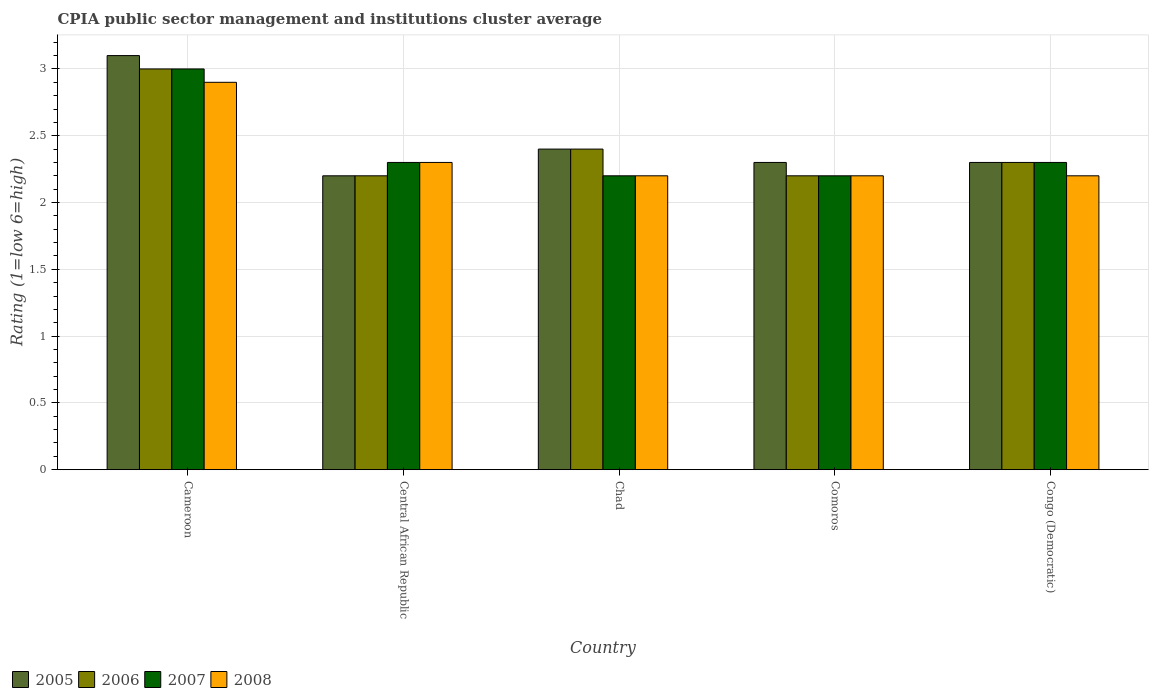How many different coloured bars are there?
Offer a very short reply. 4. How many groups of bars are there?
Provide a succinct answer. 5. Are the number of bars per tick equal to the number of legend labels?
Give a very brief answer. Yes. Are the number of bars on each tick of the X-axis equal?
Offer a very short reply. Yes. How many bars are there on the 3rd tick from the left?
Provide a succinct answer. 4. What is the label of the 5th group of bars from the left?
Your answer should be compact. Congo (Democratic). Across all countries, what is the minimum CPIA rating in 2007?
Offer a terse response. 2.2. In which country was the CPIA rating in 2008 maximum?
Provide a succinct answer. Cameroon. In which country was the CPIA rating in 2008 minimum?
Your response must be concise. Chad. What is the difference between the CPIA rating in 2006 in Chad and that in Comoros?
Make the answer very short. 0.2. What is the difference between the CPIA rating in 2005 in Chad and the CPIA rating in 2008 in Cameroon?
Provide a short and direct response. -0.5. What is the average CPIA rating in 2007 per country?
Make the answer very short. 2.4. What is the difference between the CPIA rating of/in 2006 and CPIA rating of/in 2008 in Cameroon?
Provide a succinct answer. 0.1. What is the ratio of the CPIA rating in 2007 in Chad to that in Comoros?
Provide a short and direct response. 1. Is the CPIA rating in 2007 in Cameroon less than that in Chad?
Provide a succinct answer. No. What is the difference between the highest and the second highest CPIA rating in 2007?
Offer a terse response. -0.7. What is the difference between the highest and the lowest CPIA rating in 2008?
Make the answer very short. 0.7. Is the sum of the CPIA rating in 2008 in Central African Republic and Comoros greater than the maximum CPIA rating in 2005 across all countries?
Offer a very short reply. Yes. Is it the case that in every country, the sum of the CPIA rating in 2007 and CPIA rating in 2006 is greater than the sum of CPIA rating in 2008 and CPIA rating in 2005?
Ensure brevity in your answer.  No. How many countries are there in the graph?
Offer a terse response. 5. What is the difference between two consecutive major ticks on the Y-axis?
Make the answer very short. 0.5. Are the values on the major ticks of Y-axis written in scientific E-notation?
Offer a terse response. No. Does the graph contain any zero values?
Offer a terse response. No. How many legend labels are there?
Give a very brief answer. 4. What is the title of the graph?
Ensure brevity in your answer.  CPIA public sector management and institutions cluster average. Does "2005" appear as one of the legend labels in the graph?
Offer a terse response. Yes. What is the label or title of the X-axis?
Your answer should be compact. Country. What is the label or title of the Y-axis?
Provide a short and direct response. Rating (1=low 6=high). What is the Rating (1=low 6=high) of 2005 in Cameroon?
Your answer should be compact. 3.1. What is the Rating (1=low 6=high) in 2007 in Cameroon?
Ensure brevity in your answer.  3. What is the Rating (1=low 6=high) in 2008 in Cameroon?
Keep it short and to the point. 2.9. What is the Rating (1=low 6=high) of 2006 in Central African Republic?
Ensure brevity in your answer.  2.2. What is the Rating (1=low 6=high) of 2007 in Central African Republic?
Provide a short and direct response. 2.3. What is the Rating (1=low 6=high) of 2006 in Chad?
Provide a succinct answer. 2.4. What is the Rating (1=low 6=high) in 2008 in Chad?
Give a very brief answer. 2.2. What is the Rating (1=low 6=high) in 2006 in Comoros?
Your answer should be very brief. 2.2. Across all countries, what is the maximum Rating (1=low 6=high) in 2006?
Offer a terse response. 3. Across all countries, what is the maximum Rating (1=low 6=high) of 2007?
Provide a succinct answer. 3. Across all countries, what is the minimum Rating (1=low 6=high) in 2005?
Your answer should be compact. 2.2. Across all countries, what is the minimum Rating (1=low 6=high) in 2007?
Provide a succinct answer. 2.2. Across all countries, what is the minimum Rating (1=low 6=high) in 2008?
Give a very brief answer. 2.2. What is the total Rating (1=low 6=high) in 2005 in the graph?
Your answer should be very brief. 12.3. What is the total Rating (1=low 6=high) in 2006 in the graph?
Provide a succinct answer. 12.1. What is the total Rating (1=low 6=high) of 2008 in the graph?
Provide a succinct answer. 11.8. What is the difference between the Rating (1=low 6=high) in 2006 in Cameroon and that in Central African Republic?
Offer a very short reply. 0.8. What is the difference between the Rating (1=low 6=high) of 2007 in Cameroon and that in Central African Republic?
Offer a terse response. 0.7. What is the difference between the Rating (1=low 6=high) of 2005 in Cameroon and that in Comoros?
Offer a terse response. 0.8. What is the difference between the Rating (1=low 6=high) in 2006 in Cameroon and that in Comoros?
Make the answer very short. 0.8. What is the difference between the Rating (1=low 6=high) in 2008 in Cameroon and that in Comoros?
Offer a terse response. 0.7. What is the difference between the Rating (1=low 6=high) of 2006 in Cameroon and that in Congo (Democratic)?
Give a very brief answer. 0.7. What is the difference between the Rating (1=low 6=high) of 2007 in Cameroon and that in Congo (Democratic)?
Keep it short and to the point. 0.7. What is the difference between the Rating (1=low 6=high) of 2008 in Cameroon and that in Congo (Democratic)?
Provide a short and direct response. 0.7. What is the difference between the Rating (1=low 6=high) of 2005 in Central African Republic and that in Chad?
Ensure brevity in your answer.  -0.2. What is the difference between the Rating (1=low 6=high) in 2006 in Central African Republic and that in Chad?
Ensure brevity in your answer.  -0.2. What is the difference between the Rating (1=low 6=high) of 2007 in Central African Republic and that in Chad?
Offer a very short reply. 0.1. What is the difference between the Rating (1=low 6=high) of 2008 in Central African Republic and that in Chad?
Give a very brief answer. 0.1. What is the difference between the Rating (1=low 6=high) in 2005 in Central African Republic and that in Comoros?
Ensure brevity in your answer.  -0.1. What is the difference between the Rating (1=low 6=high) in 2005 in Central African Republic and that in Congo (Democratic)?
Your answer should be compact. -0.1. What is the difference between the Rating (1=low 6=high) of 2006 in Central African Republic and that in Congo (Democratic)?
Ensure brevity in your answer.  -0.1. What is the difference between the Rating (1=low 6=high) in 2005 in Chad and that in Comoros?
Make the answer very short. 0.1. What is the difference between the Rating (1=low 6=high) of 2007 in Chad and that in Congo (Democratic)?
Offer a very short reply. -0.1. What is the difference between the Rating (1=low 6=high) of 2008 in Chad and that in Congo (Democratic)?
Give a very brief answer. 0. What is the difference between the Rating (1=low 6=high) of 2005 in Cameroon and the Rating (1=low 6=high) of 2006 in Central African Republic?
Your response must be concise. 0.9. What is the difference between the Rating (1=low 6=high) in 2005 in Cameroon and the Rating (1=low 6=high) in 2007 in Central African Republic?
Offer a very short reply. 0.8. What is the difference between the Rating (1=low 6=high) of 2005 in Cameroon and the Rating (1=low 6=high) of 2008 in Central African Republic?
Offer a terse response. 0.8. What is the difference between the Rating (1=low 6=high) of 2007 in Cameroon and the Rating (1=low 6=high) of 2008 in Central African Republic?
Your answer should be compact. 0.7. What is the difference between the Rating (1=low 6=high) of 2005 in Cameroon and the Rating (1=low 6=high) of 2006 in Chad?
Offer a very short reply. 0.7. What is the difference between the Rating (1=low 6=high) of 2005 in Cameroon and the Rating (1=low 6=high) of 2008 in Chad?
Your response must be concise. 0.9. What is the difference between the Rating (1=low 6=high) of 2007 in Cameroon and the Rating (1=low 6=high) of 2008 in Comoros?
Your answer should be very brief. 0.8. What is the difference between the Rating (1=low 6=high) of 2005 in Cameroon and the Rating (1=low 6=high) of 2007 in Congo (Democratic)?
Make the answer very short. 0.8. What is the difference between the Rating (1=low 6=high) of 2005 in Cameroon and the Rating (1=low 6=high) of 2008 in Congo (Democratic)?
Your answer should be compact. 0.9. What is the difference between the Rating (1=low 6=high) of 2006 in Cameroon and the Rating (1=low 6=high) of 2007 in Congo (Democratic)?
Provide a short and direct response. 0.7. What is the difference between the Rating (1=low 6=high) in 2007 in Cameroon and the Rating (1=low 6=high) in 2008 in Congo (Democratic)?
Provide a short and direct response. 0.8. What is the difference between the Rating (1=low 6=high) in 2005 in Central African Republic and the Rating (1=low 6=high) in 2006 in Chad?
Give a very brief answer. -0.2. What is the difference between the Rating (1=low 6=high) of 2005 in Central African Republic and the Rating (1=low 6=high) of 2008 in Chad?
Your answer should be very brief. 0. What is the difference between the Rating (1=low 6=high) in 2006 in Central African Republic and the Rating (1=low 6=high) in 2007 in Chad?
Offer a very short reply. 0. What is the difference between the Rating (1=low 6=high) in 2006 in Central African Republic and the Rating (1=low 6=high) in 2008 in Comoros?
Your answer should be compact. 0. What is the difference between the Rating (1=low 6=high) in 2007 in Central African Republic and the Rating (1=low 6=high) in 2008 in Comoros?
Your response must be concise. 0.1. What is the difference between the Rating (1=low 6=high) in 2005 in Central African Republic and the Rating (1=low 6=high) in 2008 in Congo (Democratic)?
Keep it short and to the point. 0. What is the difference between the Rating (1=low 6=high) of 2006 in Central African Republic and the Rating (1=low 6=high) of 2007 in Congo (Democratic)?
Your answer should be very brief. -0.1. What is the difference between the Rating (1=low 6=high) in 2007 in Central African Republic and the Rating (1=low 6=high) in 2008 in Congo (Democratic)?
Ensure brevity in your answer.  0.1. What is the difference between the Rating (1=low 6=high) of 2005 in Chad and the Rating (1=low 6=high) of 2006 in Comoros?
Keep it short and to the point. 0.2. What is the difference between the Rating (1=low 6=high) of 2005 in Chad and the Rating (1=low 6=high) of 2008 in Comoros?
Provide a succinct answer. 0.2. What is the difference between the Rating (1=low 6=high) of 2006 in Chad and the Rating (1=low 6=high) of 2007 in Comoros?
Offer a very short reply. 0.2. What is the difference between the Rating (1=low 6=high) of 2006 in Chad and the Rating (1=low 6=high) of 2008 in Comoros?
Make the answer very short. 0.2. What is the difference between the Rating (1=low 6=high) in 2007 in Chad and the Rating (1=low 6=high) in 2008 in Comoros?
Make the answer very short. 0. What is the difference between the Rating (1=low 6=high) of 2007 in Chad and the Rating (1=low 6=high) of 2008 in Congo (Democratic)?
Ensure brevity in your answer.  0. What is the difference between the Rating (1=low 6=high) of 2005 in Comoros and the Rating (1=low 6=high) of 2006 in Congo (Democratic)?
Your answer should be compact. 0. What is the difference between the Rating (1=low 6=high) of 2005 in Comoros and the Rating (1=low 6=high) of 2008 in Congo (Democratic)?
Your answer should be compact. 0.1. What is the difference between the Rating (1=low 6=high) of 2006 in Comoros and the Rating (1=low 6=high) of 2007 in Congo (Democratic)?
Your answer should be very brief. -0.1. What is the difference between the Rating (1=low 6=high) of 2006 in Comoros and the Rating (1=low 6=high) of 2008 in Congo (Democratic)?
Keep it short and to the point. 0. What is the average Rating (1=low 6=high) of 2005 per country?
Ensure brevity in your answer.  2.46. What is the average Rating (1=low 6=high) of 2006 per country?
Offer a very short reply. 2.42. What is the average Rating (1=low 6=high) of 2008 per country?
Make the answer very short. 2.36. What is the difference between the Rating (1=low 6=high) in 2005 and Rating (1=low 6=high) in 2008 in Cameroon?
Your answer should be very brief. 0.2. What is the difference between the Rating (1=low 6=high) in 2006 and Rating (1=low 6=high) in 2007 in Cameroon?
Give a very brief answer. 0. What is the difference between the Rating (1=low 6=high) of 2006 and Rating (1=low 6=high) of 2008 in Cameroon?
Offer a very short reply. 0.1. What is the difference between the Rating (1=low 6=high) of 2005 and Rating (1=low 6=high) of 2006 in Central African Republic?
Give a very brief answer. 0. What is the difference between the Rating (1=low 6=high) in 2005 and Rating (1=low 6=high) in 2007 in Central African Republic?
Give a very brief answer. -0.1. What is the difference between the Rating (1=low 6=high) of 2005 and Rating (1=low 6=high) of 2008 in Central African Republic?
Keep it short and to the point. -0.1. What is the difference between the Rating (1=low 6=high) of 2005 and Rating (1=low 6=high) of 2007 in Chad?
Your answer should be very brief. 0.2. What is the difference between the Rating (1=low 6=high) of 2006 and Rating (1=low 6=high) of 2008 in Chad?
Your answer should be very brief. 0.2. What is the difference between the Rating (1=low 6=high) of 2005 and Rating (1=low 6=high) of 2006 in Comoros?
Your answer should be compact. 0.1. What is the difference between the Rating (1=low 6=high) of 2006 and Rating (1=low 6=high) of 2007 in Comoros?
Offer a terse response. 0. What is the difference between the Rating (1=low 6=high) in 2007 and Rating (1=low 6=high) in 2008 in Comoros?
Provide a succinct answer. 0. What is the difference between the Rating (1=low 6=high) in 2005 and Rating (1=low 6=high) in 2006 in Congo (Democratic)?
Offer a terse response. 0. What is the difference between the Rating (1=low 6=high) in 2005 and Rating (1=low 6=high) in 2007 in Congo (Democratic)?
Provide a succinct answer. 0. What is the difference between the Rating (1=low 6=high) in 2005 and Rating (1=low 6=high) in 2008 in Congo (Democratic)?
Give a very brief answer. 0.1. What is the difference between the Rating (1=low 6=high) in 2006 and Rating (1=low 6=high) in 2008 in Congo (Democratic)?
Your answer should be very brief. 0.1. What is the ratio of the Rating (1=low 6=high) of 2005 in Cameroon to that in Central African Republic?
Give a very brief answer. 1.41. What is the ratio of the Rating (1=low 6=high) of 2006 in Cameroon to that in Central African Republic?
Provide a succinct answer. 1.36. What is the ratio of the Rating (1=low 6=high) of 2007 in Cameroon to that in Central African Republic?
Keep it short and to the point. 1.3. What is the ratio of the Rating (1=low 6=high) of 2008 in Cameroon to that in Central African Republic?
Your response must be concise. 1.26. What is the ratio of the Rating (1=low 6=high) of 2005 in Cameroon to that in Chad?
Your answer should be compact. 1.29. What is the ratio of the Rating (1=low 6=high) of 2006 in Cameroon to that in Chad?
Your answer should be very brief. 1.25. What is the ratio of the Rating (1=low 6=high) of 2007 in Cameroon to that in Chad?
Offer a very short reply. 1.36. What is the ratio of the Rating (1=low 6=high) of 2008 in Cameroon to that in Chad?
Provide a short and direct response. 1.32. What is the ratio of the Rating (1=low 6=high) of 2005 in Cameroon to that in Comoros?
Give a very brief answer. 1.35. What is the ratio of the Rating (1=low 6=high) of 2006 in Cameroon to that in Comoros?
Give a very brief answer. 1.36. What is the ratio of the Rating (1=low 6=high) in 2007 in Cameroon to that in Comoros?
Provide a succinct answer. 1.36. What is the ratio of the Rating (1=low 6=high) in 2008 in Cameroon to that in Comoros?
Ensure brevity in your answer.  1.32. What is the ratio of the Rating (1=low 6=high) in 2005 in Cameroon to that in Congo (Democratic)?
Your answer should be compact. 1.35. What is the ratio of the Rating (1=low 6=high) of 2006 in Cameroon to that in Congo (Democratic)?
Make the answer very short. 1.3. What is the ratio of the Rating (1=low 6=high) of 2007 in Cameroon to that in Congo (Democratic)?
Give a very brief answer. 1.3. What is the ratio of the Rating (1=low 6=high) of 2008 in Cameroon to that in Congo (Democratic)?
Provide a short and direct response. 1.32. What is the ratio of the Rating (1=low 6=high) of 2005 in Central African Republic to that in Chad?
Make the answer very short. 0.92. What is the ratio of the Rating (1=low 6=high) in 2007 in Central African Republic to that in Chad?
Ensure brevity in your answer.  1.05. What is the ratio of the Rating (1=low 6=high) of 2008 in Central African Republic to that in Chad?
Ensure brevity in your answer.  1.05. What is the ratio of the Rating (1=low 6=high) in 2005 in Central African Republic to that in Comoros?
Ensure brevity in your answer.  0.96. What is the ratio of the Rating (1=low 6=high) in 2007 in Central African Republic to that in Comoros?
Your answer should be compact. 1.05. What is the ratio of the Rating (1=low 6=high) in 2008 in Central African Republic to that in Comoros?
Your answer should be very brief. 1.05. What is the ratio of the Rating (1=low 6=high) of 2005 in Central African Republic to that in Congo (Democratic)?
Your response must be concise. 0.96. What is the ratio of the Rating (1=low 6=high) in 2006 in Central African Republic to that in Congo (Democratic)?
Your response must be concise. 0.96. What is the ratio of the Rating (1=low 6=high) of 2007 in Central African Republic to that in Congo (Democratic)?
Offer a terse response. 1. What is the ratio of the Rating (1=low 6=high) of 2008 in Central African Republic to that in Congo (Democratic)?
Provide a short and direct response. 1.05. What is the ratio of the Rating (1=low 6=high) in 2005 in Chad to that in Comoros?
Your answer should be very brief. 1.04. What is the ratio of the Rating (1=low 6=high) of 2007 in Chad to that in Comoros?
Ensure brevity in your answer.  1. What is the ratio of the Rating (1=low 6=high) of 2008 in Chad to that in Comoros?
Provide a short and direct response. 1. What is the ratio of the Rating (1=low 6=high) of 2005 in Chad to that in Congo (Democratic)?
Offer a terse response. 1.04. What is the ratio of the Rating (1=low 6=high) in 2006 in Chad to that in Congo (Democratic)?
Your answer should be very brief. 1.04. What is the ratio of the Rating (1=low 6=high) of 2007 in Chad to that in Congo (Democratic)?
Give a very brief answer. 0.96. What is the ratio of the Rating (1=low 6=high) in 2008 in Chad to that in Congo (Democratic)?
Your answer should be very brief. 1. What is the ratio of the Rating (1=low 6=high) of 2005 in Comoros to that in Congo (Democratic)?
Make the answer very short. 1. What is the ratio of the Rating (1=low 6=high) of 2006 in Comoros to that in Congo (Democratic)?
Your answer should be very brief. 0.96. What is the ratio of the Rating (1=low 6=high) of 2007 in Comoros to that in Congo (Democratic)?
Your response must be concise. 0.96. What is the difference between the highest and the second highest Rating (1=low 6=high) of 2005?
Ensure brevity in your answer.  0.7. What is the difference between the highest and the second highest Rating (1=low 6=high) of 2008?
Offer a terse response. 0.6. What is the difference between the highest and the lowest Rating (1=low 6=high) in 2006?
Keep it short and to the point. 0.8. What is the difference between the highest and the lowest Rating (1=low 6=high) in 2007?
Your answer should be very brief. 0.8. 